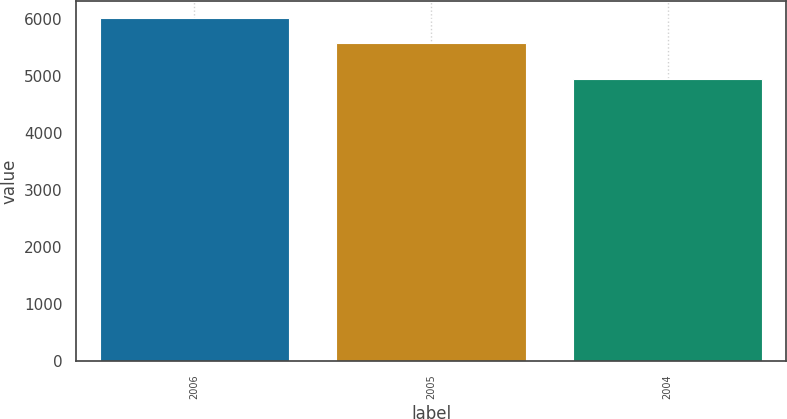Convert chart. <chart><loc_0><loc_0><loc_500><loc_500><bar_chart><fcel>2006<fcel>2005<fcel>2004<nl><fcel>6022<fcel>5575<fcel>4950<nl></chart> 